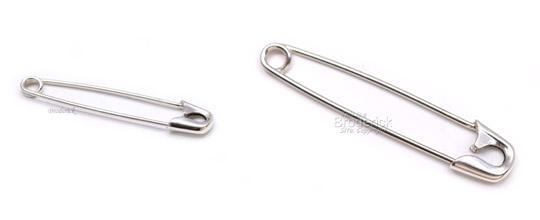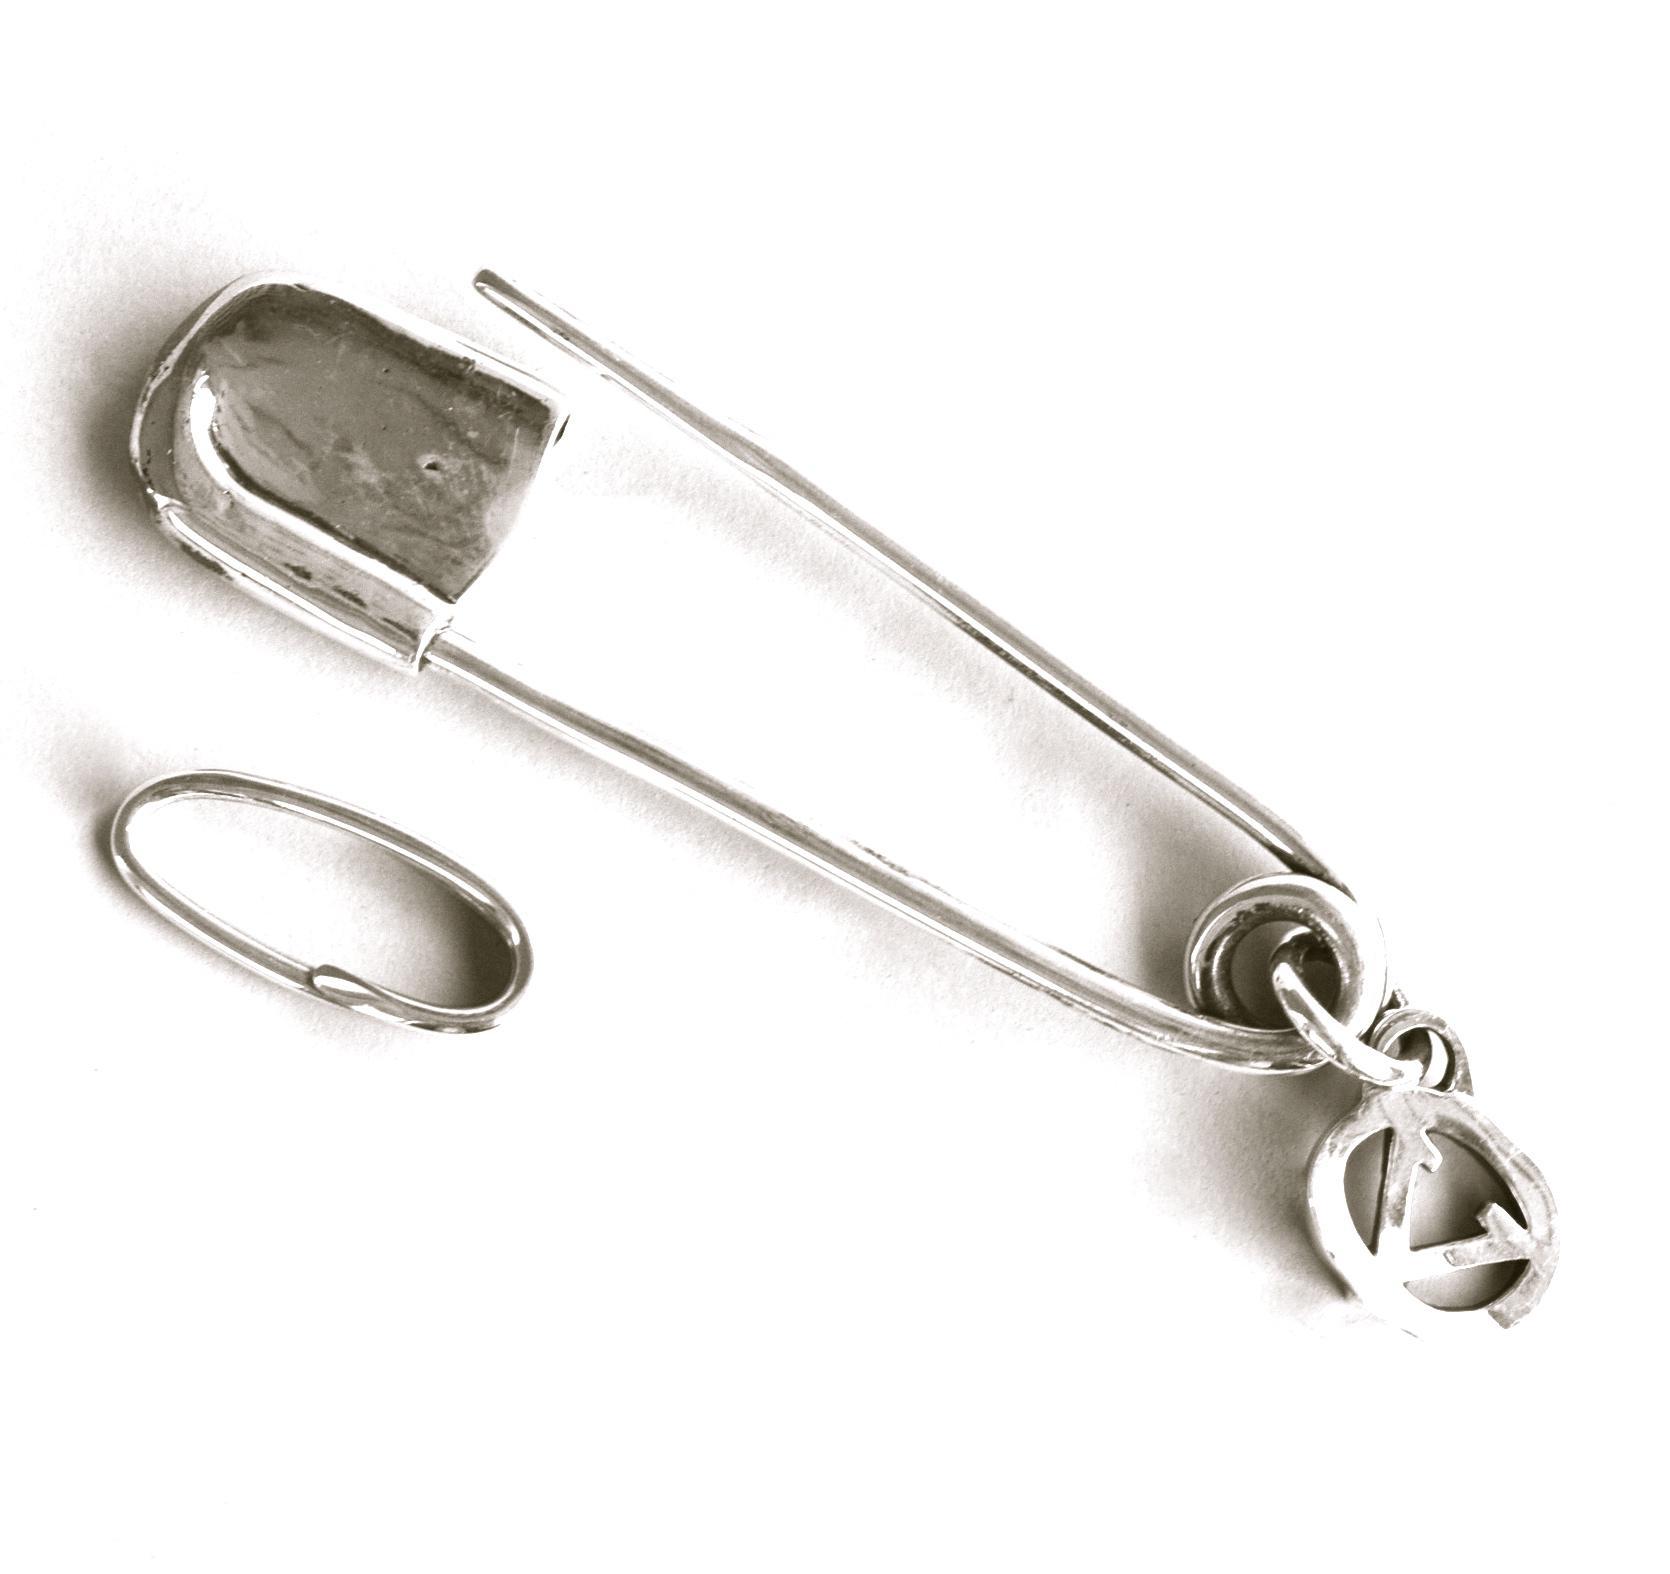The first image is the image on the left, the second image is the image on the right. For the images shown, is this caption "An image shows exactly one safety pin, which is strung with a horse-head shape charm." true? Answer yes or no. No. The first image is the image on the left, the second image is the image on the right. Assess this claim about the two images: "One image shows exactly two pins and both of those pins are closed.". Correct or not? Answer yes or no. Yes. 